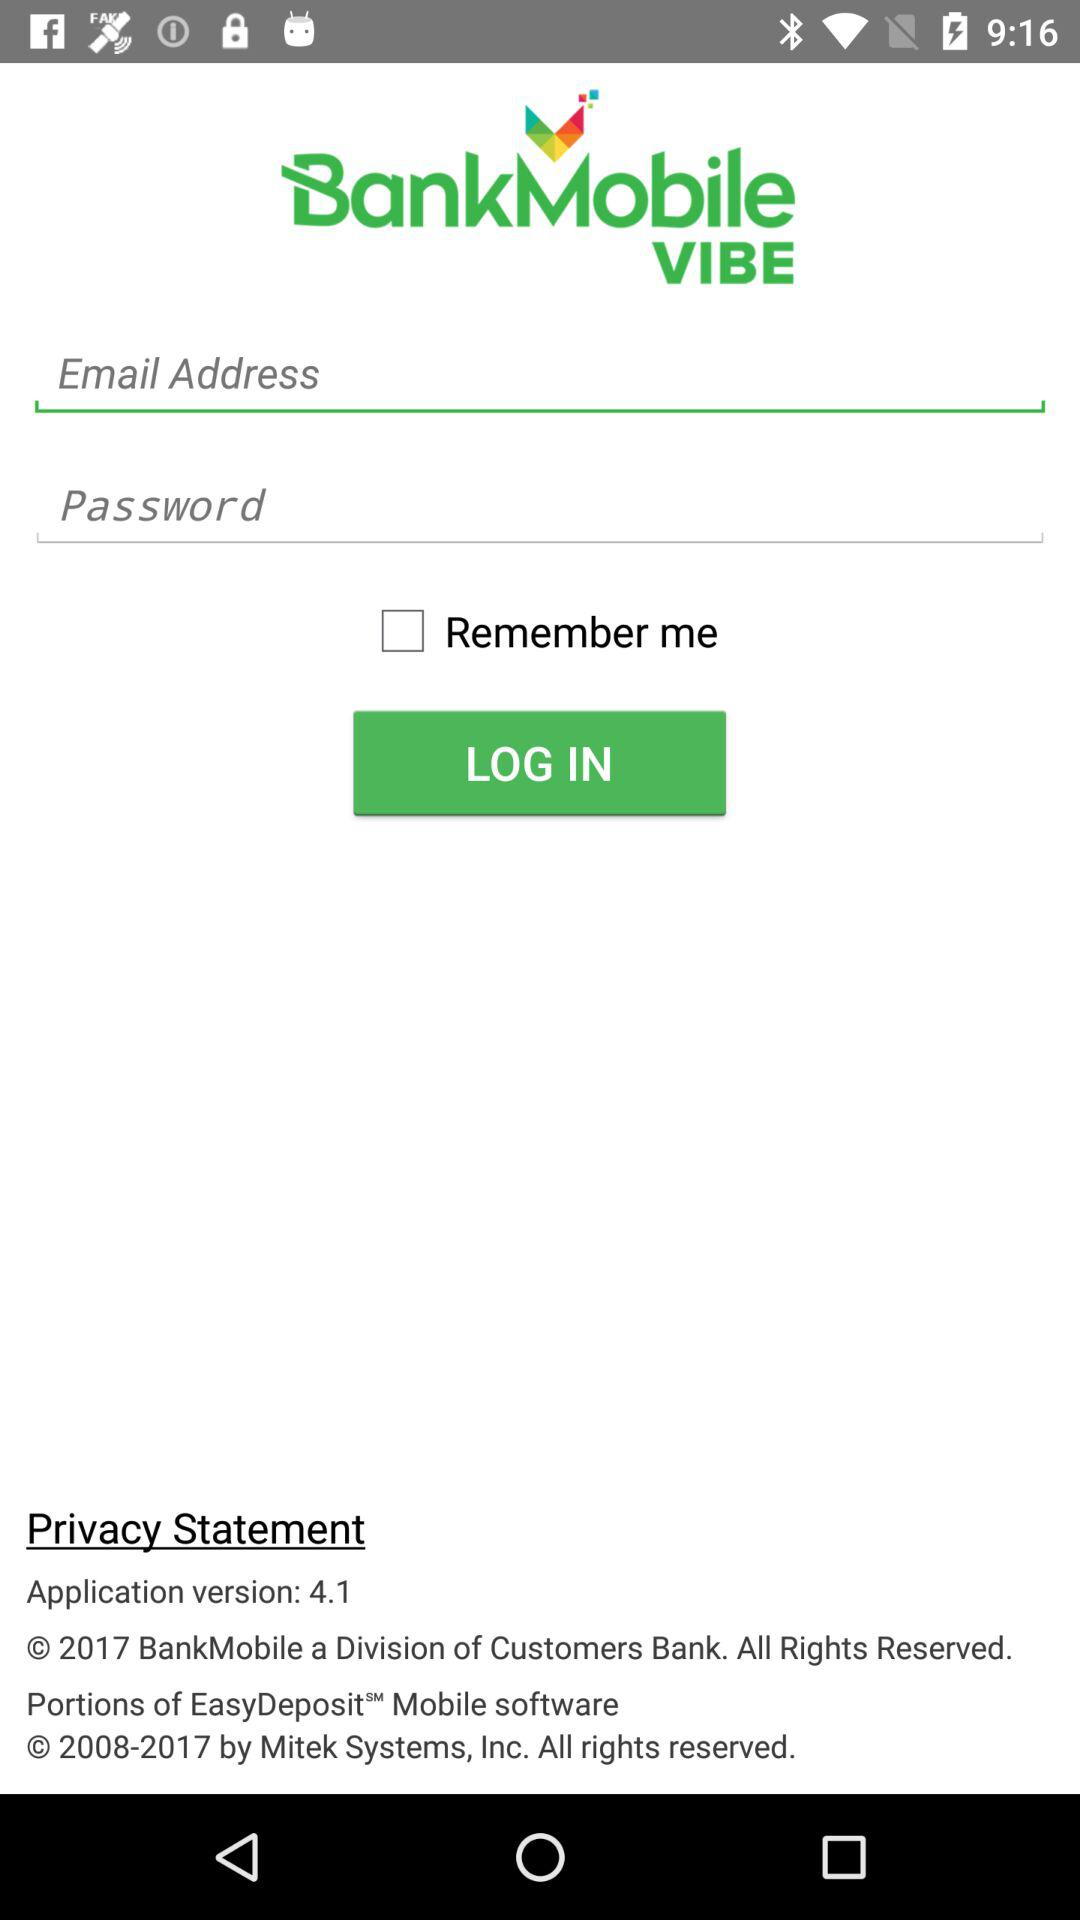What is the application name? The application name is "BankMobile VIBE". 